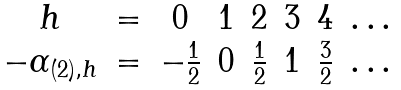Convert formula to latex. <formula><loc_0><loc_0><loc_500><loc_500>\begin{matrix} h & = & 0 & 1 & 2 & 3 & 4 & \dots \\ - \alpha _ { ( 2 ) , h } & = & - \frac { 1 } { 2 } & 0 & \frac { 1 } { 2 } & 1 & \frac { 3 } { 2 } & \dots \end{matrix}</formula> 